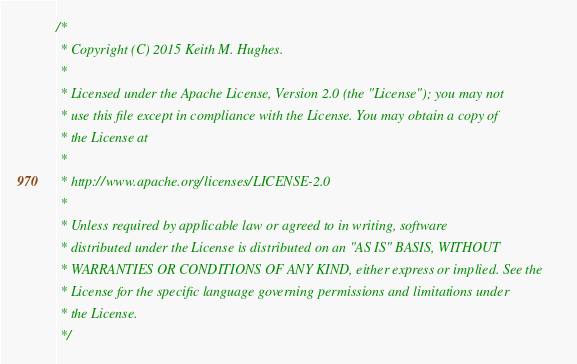<code> <loc_0><loc_0><loc_500><loc_500><_Scala_>/*
 * Copyright (C) 2015 Keith M. Hughes.
 *
 * Licensed under the Apache License, Version 2.0 (the "License"); you may not
 * use this file except in compliance with the License. You may obtain a copy of
 * the License at
 *
 * http://www.apache.org/licenses/LICENSE-2.0
 *
 * Unless required by applicable law or agreed to in writing, software
 * distributed under the License is distributed on an "AS IS" BASIS, WITHOUT
 * WARRANTIES OR CONDITIONS OF ANY KIND, either express or implied. See the
 * License for the specific language governing permissions and limitations under
 * the License.
 */
</code> 